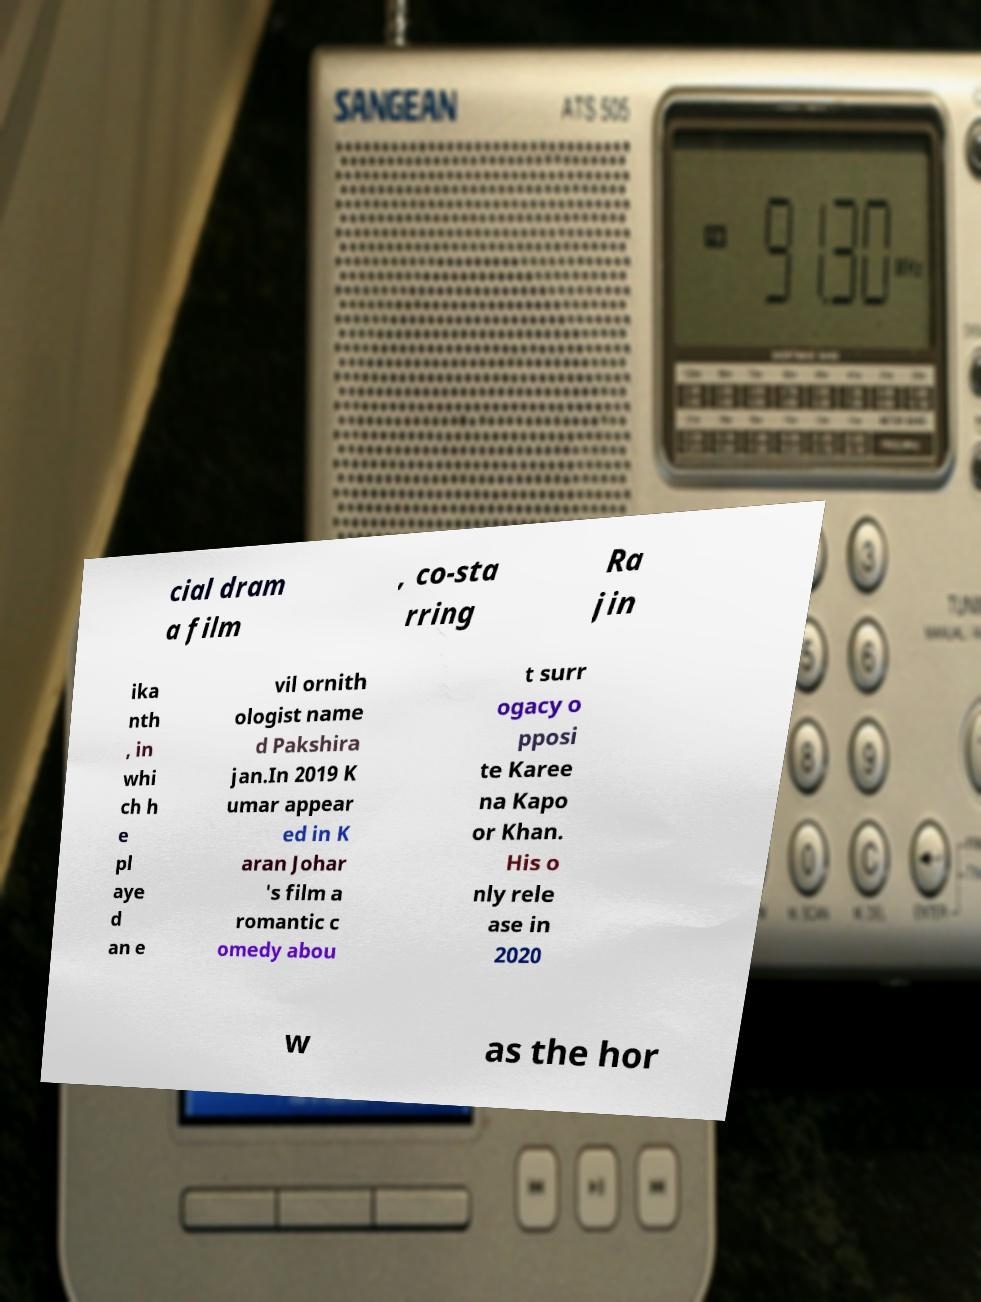Can you accurately transcribe the text from the provided image for me? cial dram a film , co-sta rring Ra jin ika nth , in whi ch h e pl aye d an e vil ornith ologist name d Pakshira jan.In 2019 K umar appear ed in K aran Johar 's film a romantic c omedy abou t surr ogacy o pposi te Karee na Kapo or Khan. His o nly rele ase in 2020 w as the hor 